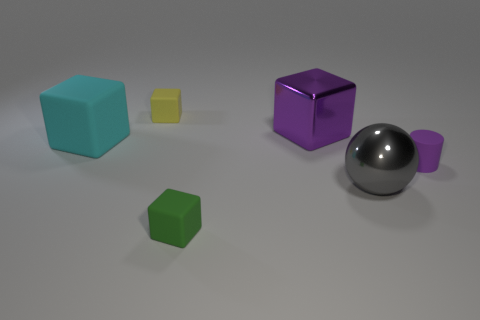There is a small object that is the same color as the large shiny block; what is it made of?
Ensure brevity in your answer.  Rubber. There is a purple object that is the same size as the cyan rubber object; what shape is it?
Keep it short and to the point. Cube. Is the material of the big purple cube the same as the yellow block?
Your response must be concise. No. How many rubber objects are purple objects or small objects?
Offer a terse response. 3. What is the shape of the large object that is the same color as the matte cylinder?
Your answer should be compact. Cube. There is a matte object that is behind the big cyan rubber object; is its color the same as the cylinder?
Provide a succinct answer. No. What shape is the tiny object that is behind the large block that is left of the big purple shiny object?
Your answer should be very brief. Cube. How many things are rubber cubes that are behind the small cylinder or gray things that are to the right of the cyan block?
Your answer should be compact. 3. What is the shape of the tiny purple thing that is the same material as the yellow cube?
Your response must be concise. Cylinder. Is there any other thing of the same color as the matte cylinder?
Provide a succinct answer. Yes. 